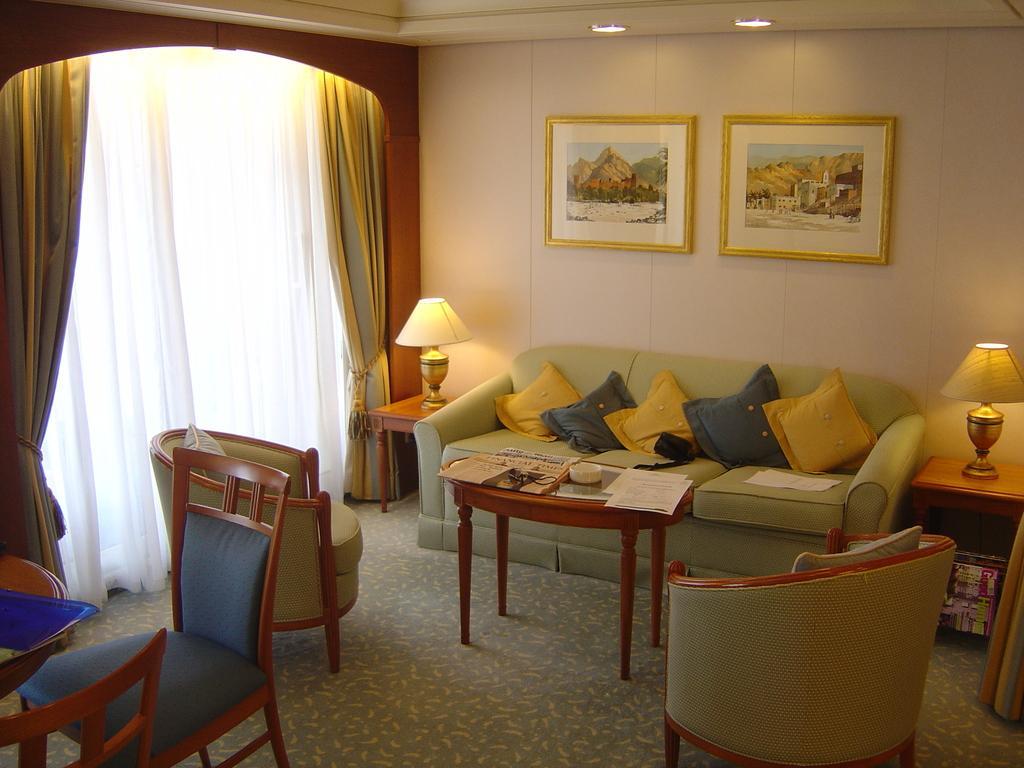Can you describe this image briefly? This image has a sofa at the middle of the image with different colours of cushions on it. There is a table with few papers and bowl on it. Left side there are few chairs. Right side there is a table on which a lamp is there. To the wall there are few picture frames attached. Left side curtains are there. 